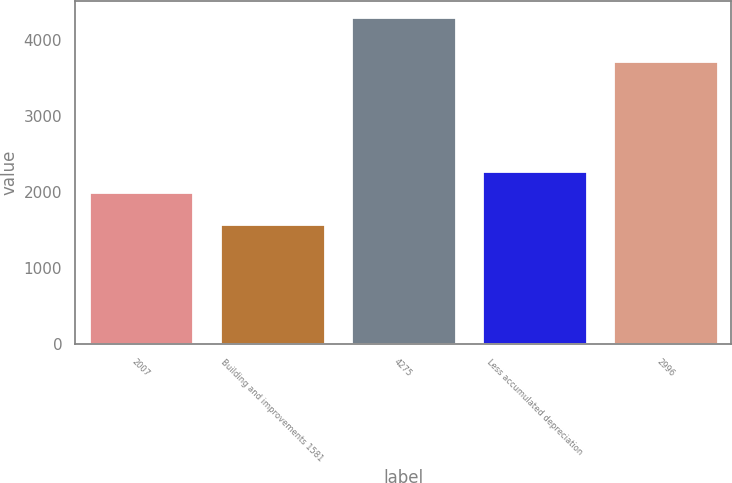Convert chart. <chart><loc_0><loc_0><loc_500><loc_500><bar_chart><fcel>2007<fcel>Building and improvements 1581<fcel>4275<fcel>Less accumulated depreciation<fcel>2996<nl><fcel>2006<fcel>1581<fcel>4306<fcel>2278.5<fcel>3731<nl></chart> 